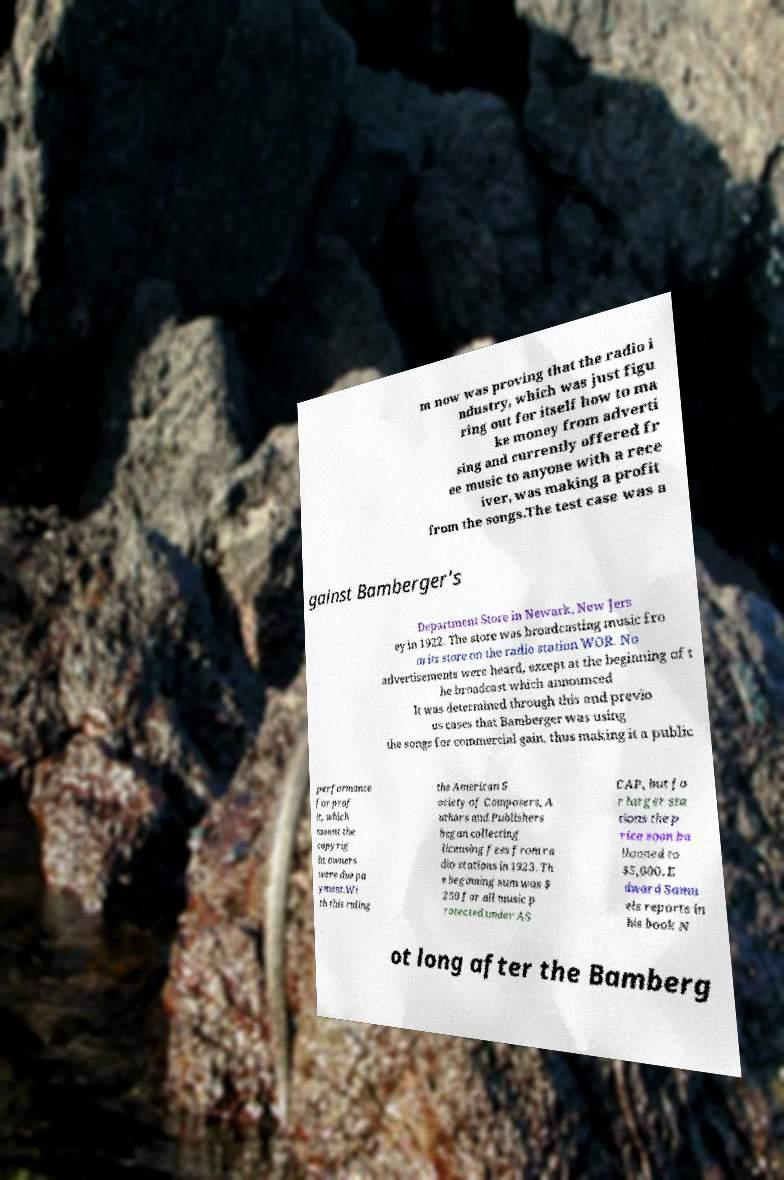Can you accurately transcribe the text from the provided image for me? m now was proving that the radio i ndustry, which was just figu ring out for itself how to ma ke money from adverti sing and currently offered fr ee music to anyone with a rece iver, was making a profit from the songs.The test case was a gainst Bamberger's Department Store in Newark, New Jers ey in 1922. The store was broadcasting music fro m its store on the radio station WOR. No advertisements were heard, except at the beginning of t he broadcast which announced It was determined through this and previo us cases that Bamberger was using the songs for commercial gain, thus making it a public performance for prof it, which meant the copyrig ht owners were due pa yment.Wi th this ruling the American S ociety of Composers, A uthors and Publishers began collecting licensing fees from ra dio stations in 1923. Th e beginning sum was $ 250 for all music p rotected under AS CAP, but fo r larger sta tions the p rice soon ba llooned to $5,000. E dward Samu els reports in his book N ot long after the Bamberg 